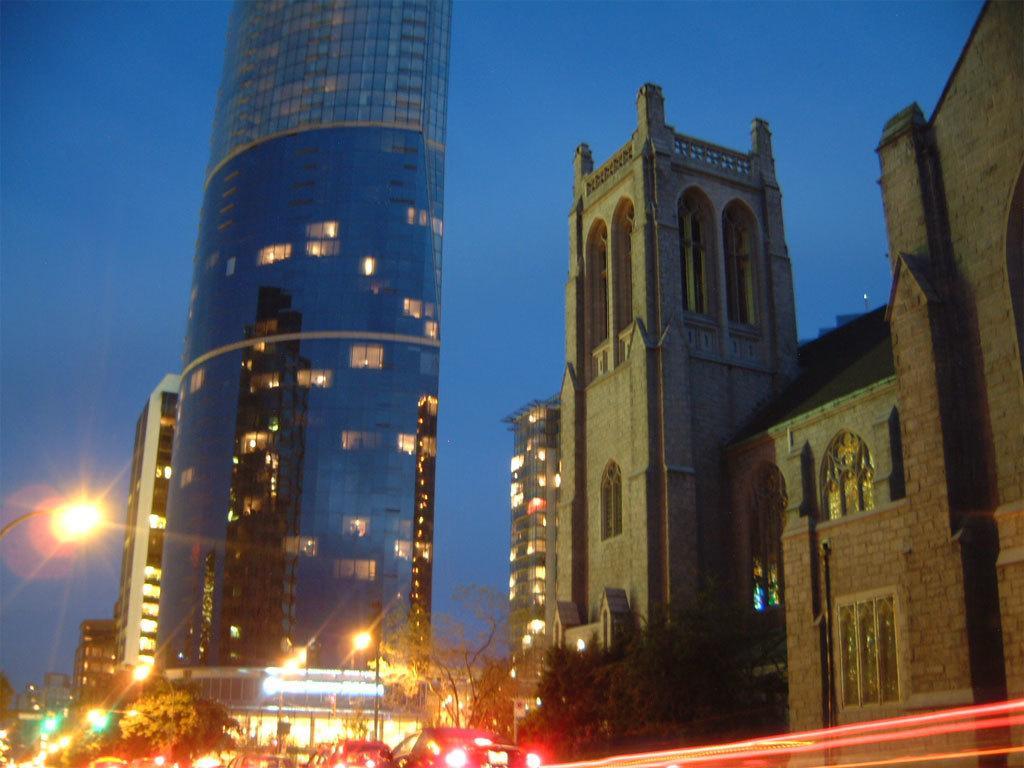In one or two sentences, can you explain what this image depicts? In this picture we can see a glass building seen in the middle of the image. In front bottom we can see some car moving on the road. On the right side you can see brick castle house with arch windows. 